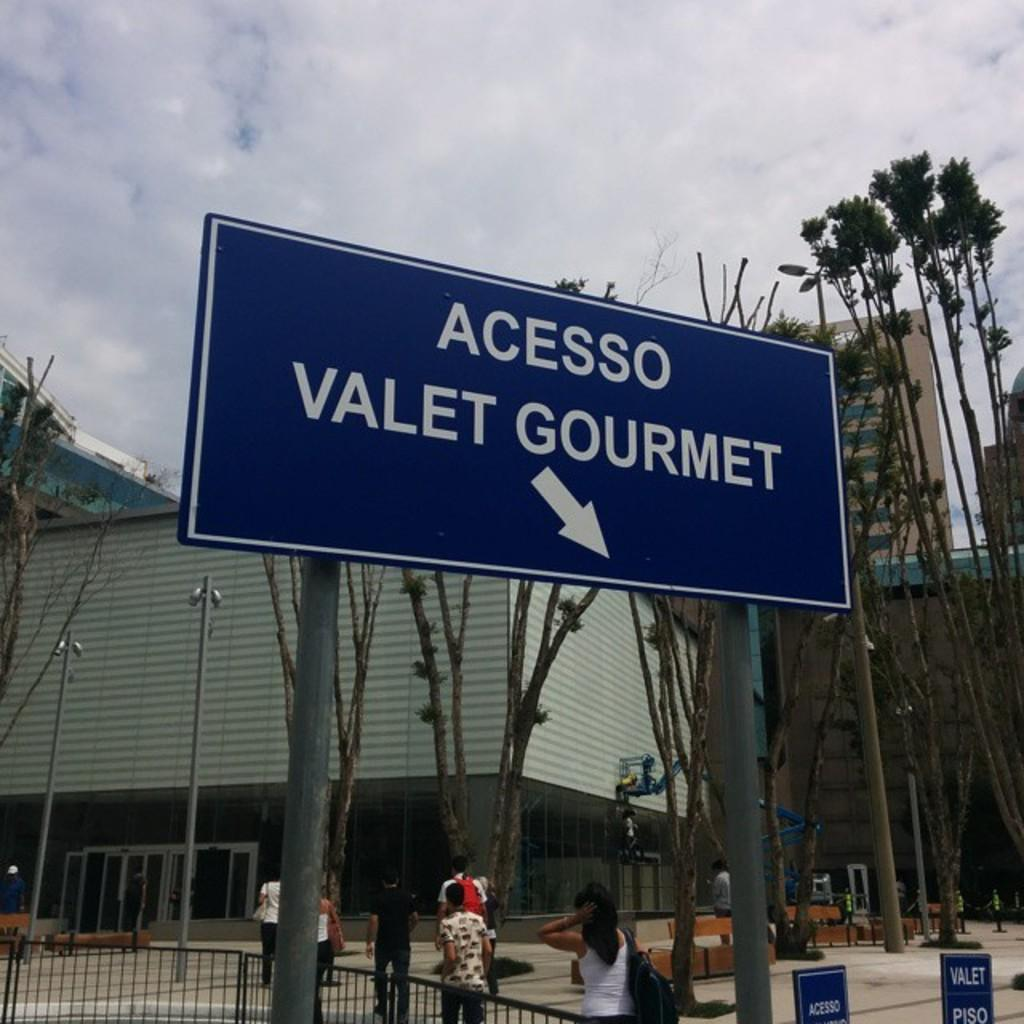<image>
Provide a brief description of the given image. A sign with a big arrow points people to "Acesso Valet Gourmet". 